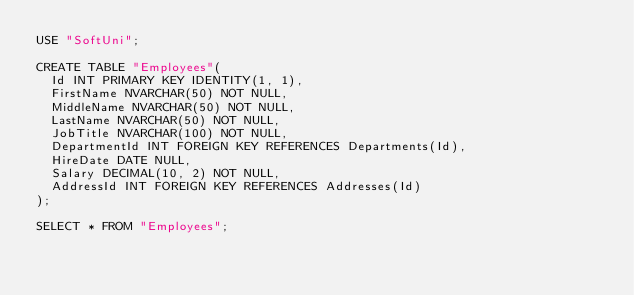Convert code to text. <code><loc_0><loc_0><loc_500><loc_500><_SQL_>USE "SoftUni";

CREATE TABLE "Employees"(
	Id INT PRIMARY KEY IDENTITY(1, 1),
	FirstName NVARCHAR(50) NOT NULL,
	MiddleName NVARCHAR(50) NOT NULL,
	LastName NVARCHAR(50) NOT NULL,
	JobTitle NVARCHAR(100) NOT NULL,
	DepartmentId INT FOREIGN KEY REFERENCES Departments(Id),
	HireDate DATE NULL,
	Salary DECIMAL(10, 2) NOT NULL,
	AddressId INT FOREIGN KEY REFERENCES Addresses(Id)
);

SELECT * FROM "Employees";</code> 